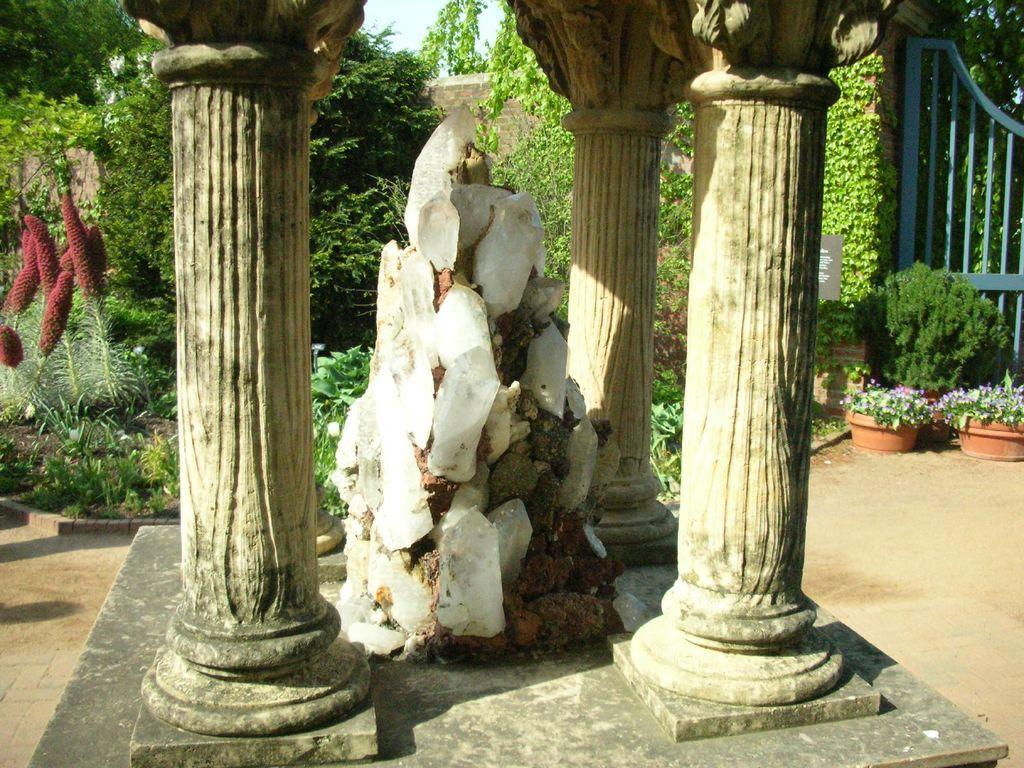Please provide a concise description of this image. In the center of the image there is a stone structure. There are pillars. In the background of the image there are plants,trees. To the right side of the image there is gate. At the bottom of the image there is floor. 